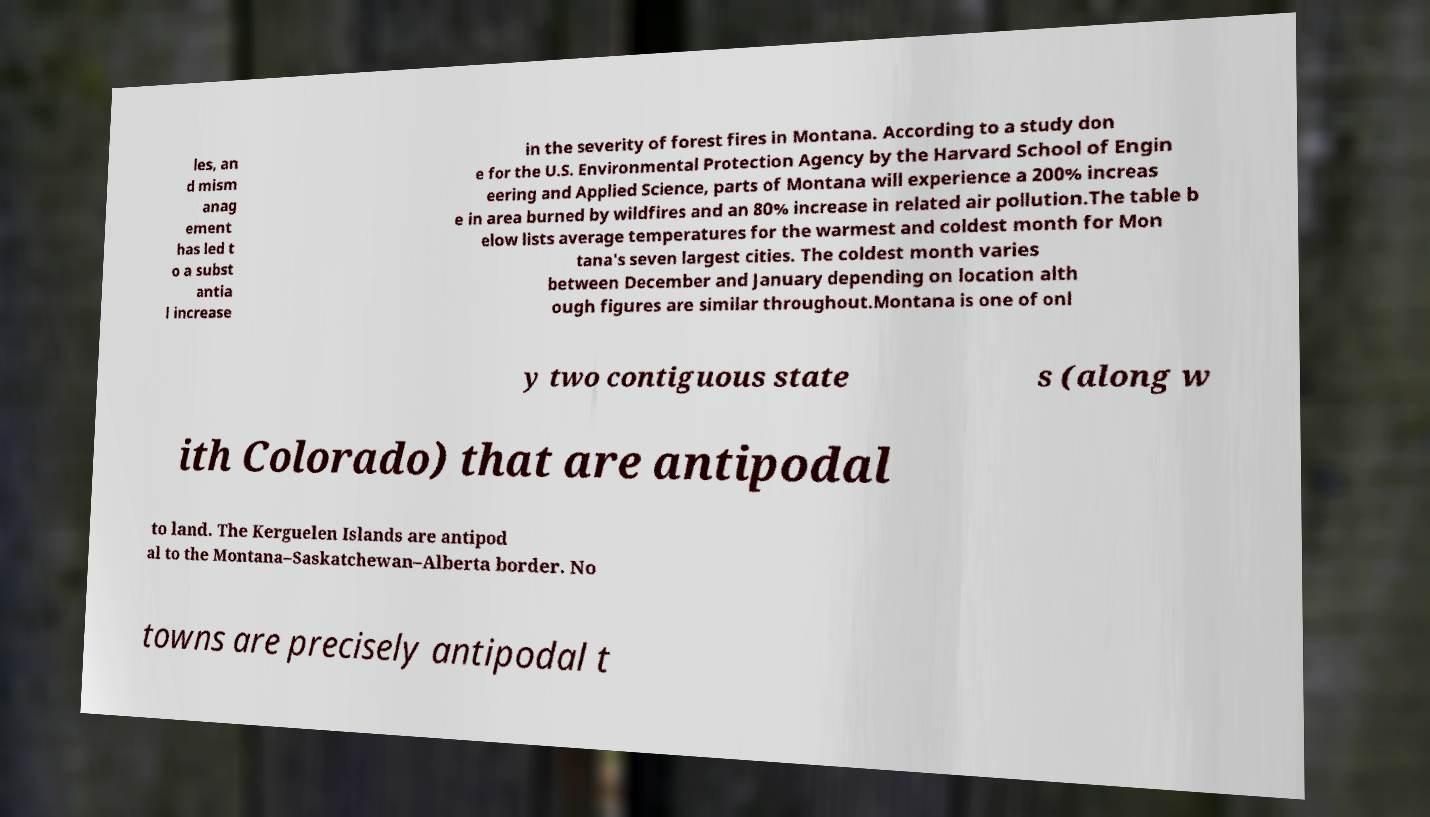What messages or text are displayed in this image? I need them in a readable, typed format. les, an d mism anag ement has led t o a subst antia l increase in the severity of forest fires in Montana. According to a study don e for the U.S. Environmental Protection Agency by the Harvard School of Engin eering and Applied Science, parts of Montana will experience a 200% increas e in area burned by wildfires and an 80% increase in related air pollution.The table b elow lists average temperatures for the warmest and coldest month for Mon tana's seven largest cities. The coldest month varies between December and January depending on location alth ough figures are similar throughout.Montana is one of onl y two contiguous state s (along w ith Colorado) that are antipodal to land. The Kerguelen Islands are antipod al to the Montana–Saskatchewan–Alberta border. No towns are precisely antipodal t 